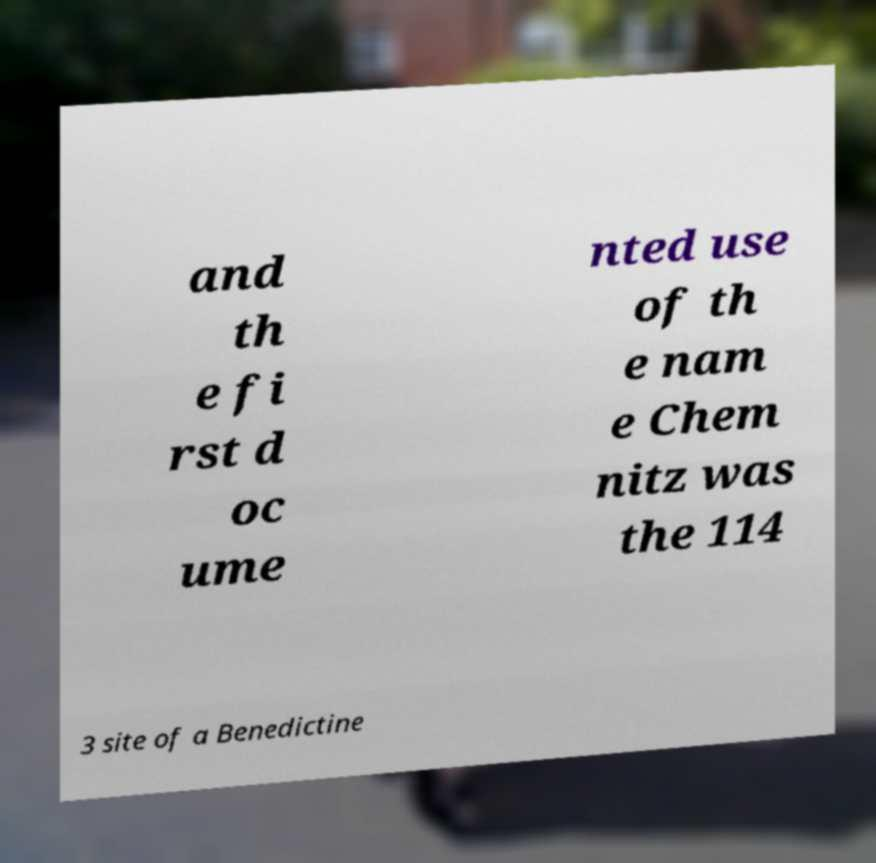Could you assist in decoding the text presented in this image and type it out clearly? and th e fi rst d oc ume nted use of th e nam e Chem nitz was the 114 3 site of a Benedictine 